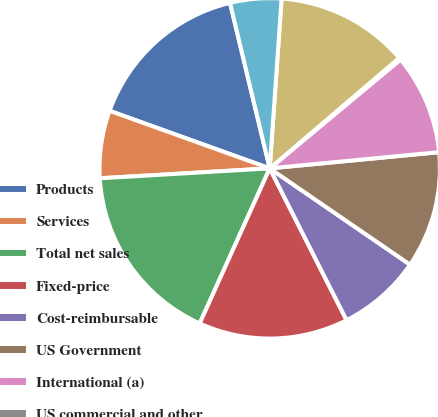<chart> <loc_0><loc_0><loc_500><loc_500><pie_chart><fcel>Products<fcel>Services<fcel>Total net sales<fcel>Fixed-price<fcel>Cost-reimbursable<fcel>US Government<fcel>International (a)<fcel>US commercial and other<fcel>United States<fcel>Asia Pacific<nl><fcel>15.76%<fcel>6.42%<fcel>17.32%<fcel>14.21%<fcel>7.97%<fcel>11.09%<fcel>9.53%<fcel>0.19%<fcel>12.65%<fcel>4.86%<nl></chart> 